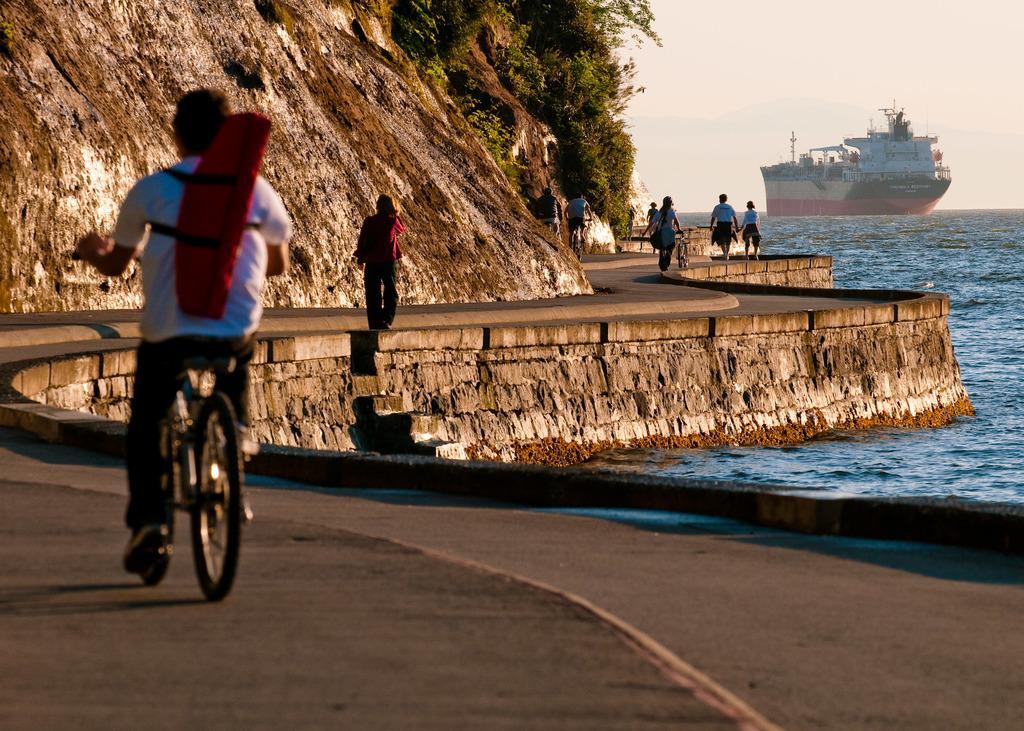Could you give a brief overview of what you see in this image? This is an outside view. In this image I can see few people are riding their bicycles on the road. On the left side, I can see a rock and some plants. On the right side there is an ocean and also I can see a ship. At the top of the image I can see the sky. 